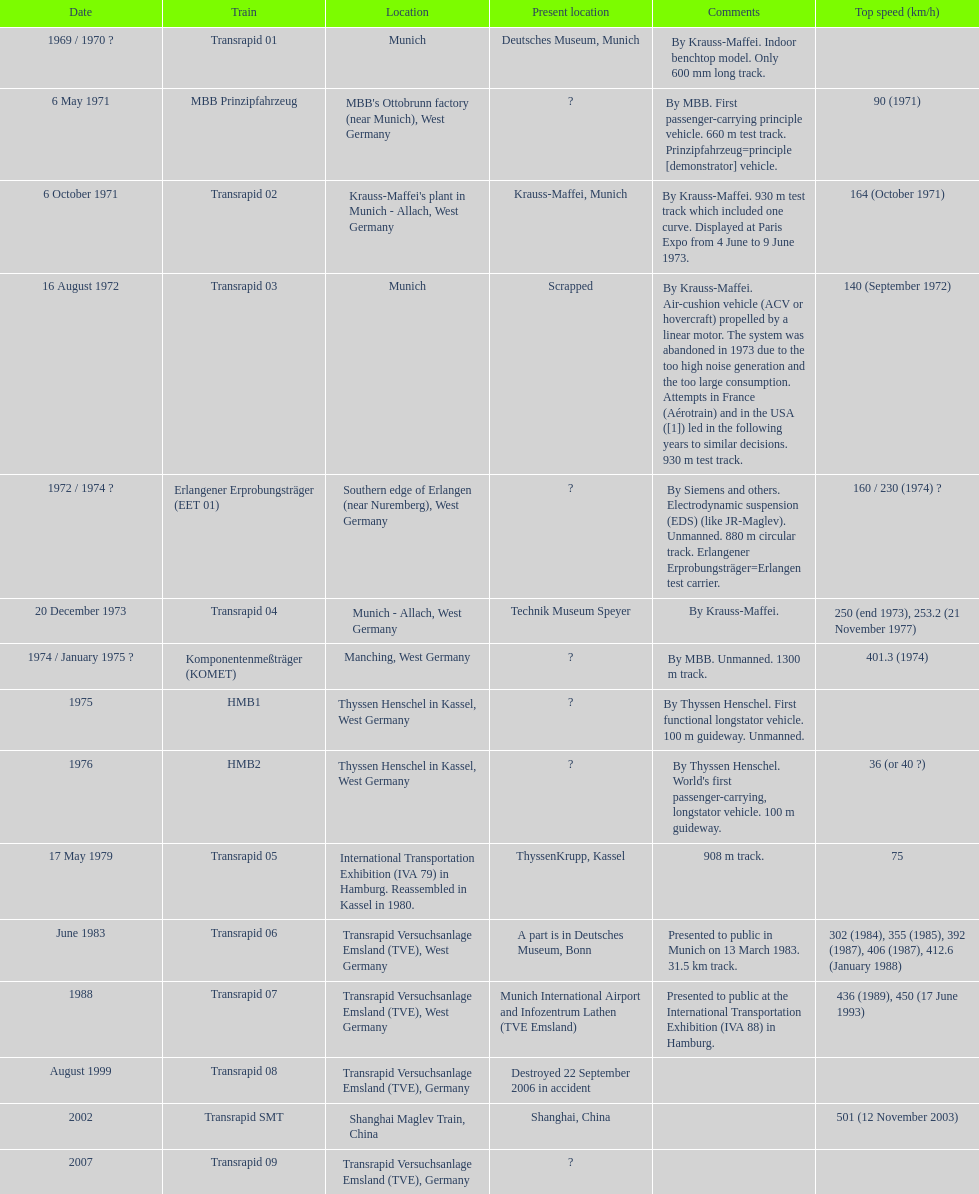What is the count of trains that were either dismantled or demolished? 2. 